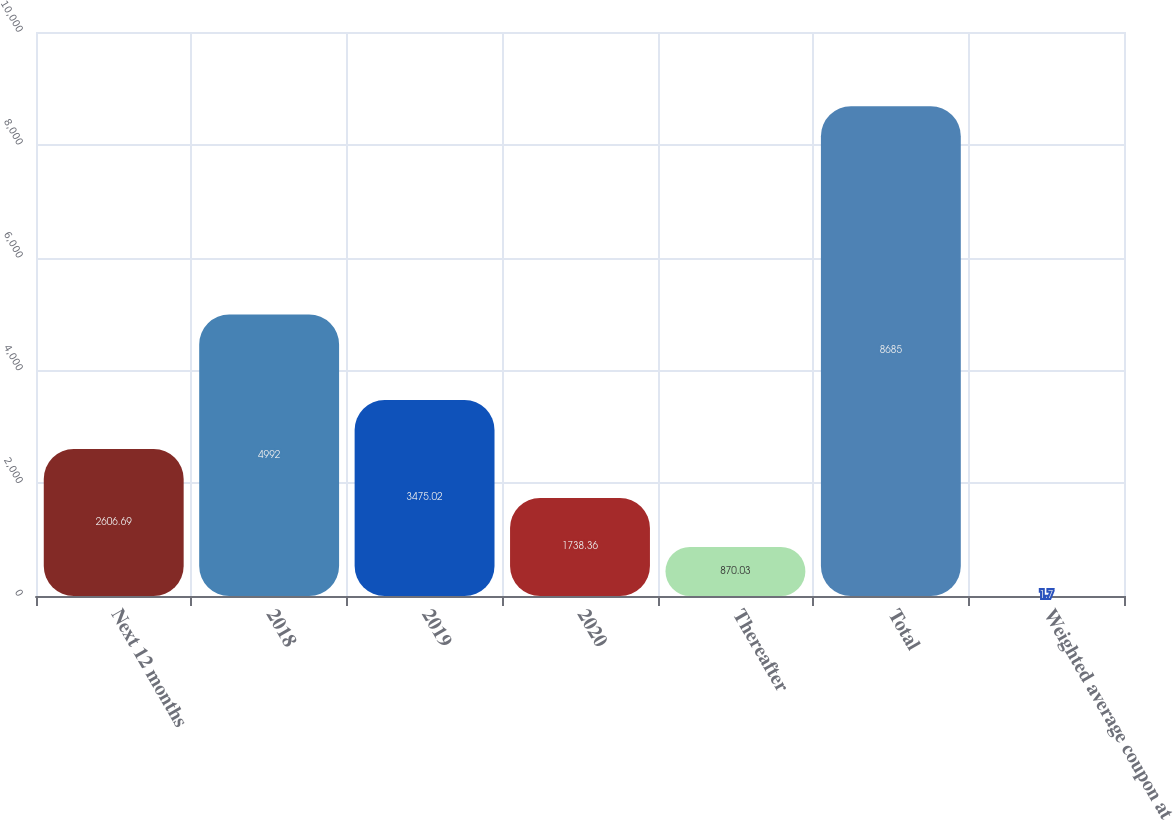Convert chart. <chart><loc_0><loc_0><loc_500><loc_500><bar_chart><fcel>Next 12 months<fcel>2018<fcel>2019<fcel>2020<fcel>Thereafter<fcel>Total<fcel>Weighted average coupon at<nl><fcel>2606.69<fcel>4992<fcel>3475.02<fcel>1738.36<fcel>870.03<fcel>8685<fcel>1.7<nl></chart> 